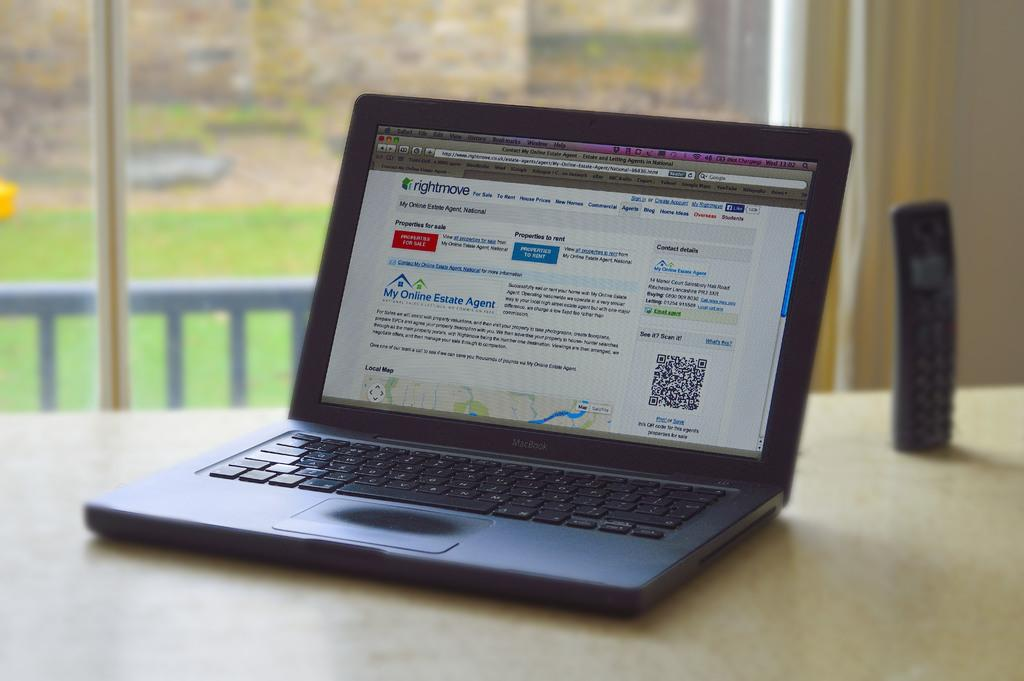<image>
Offer a succinct explanation of the picture presented. A laptop screen that has the website "Rightmove" open. 